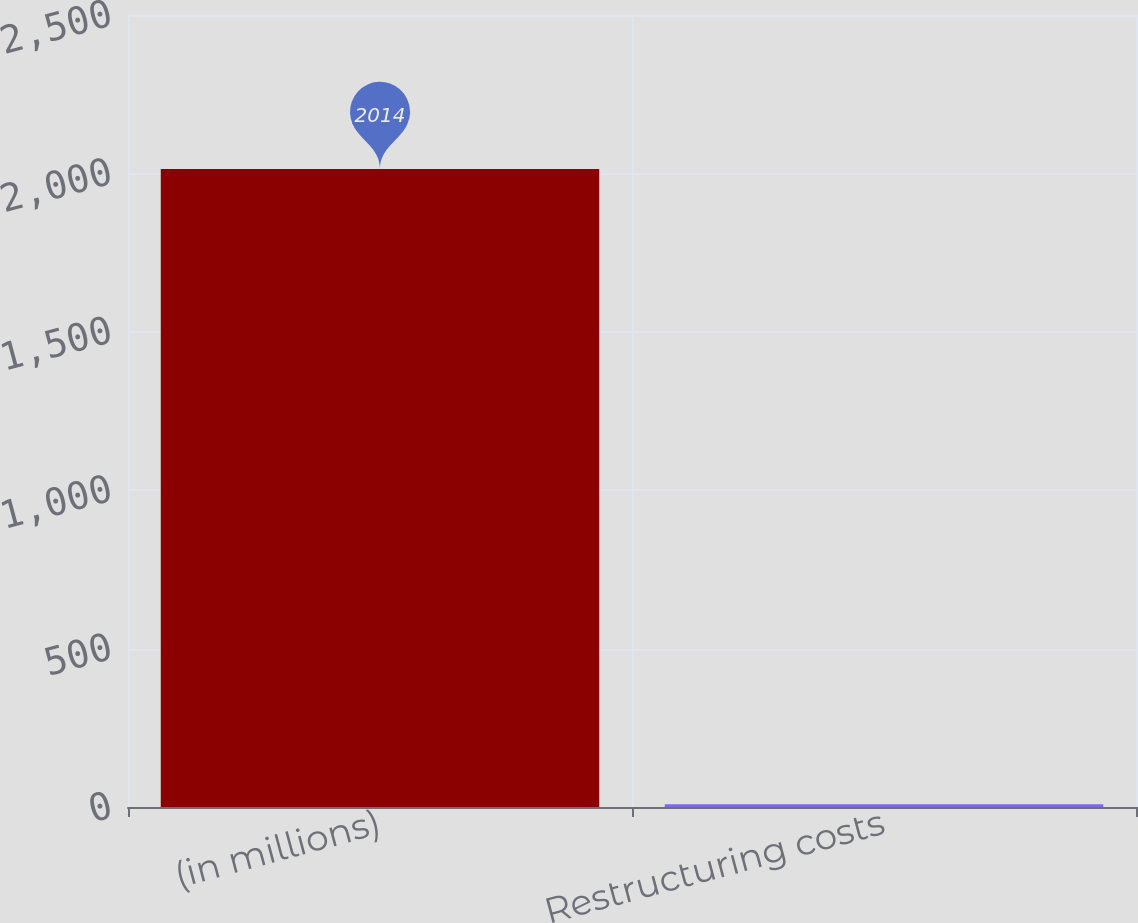<chart> <loc_0><loc_0><loc_500><loc_500><bar_chart><fcel>(in millions)<fcel>Restructuring costs<nl><fcel>2014<fcel>9<nl></chart> 